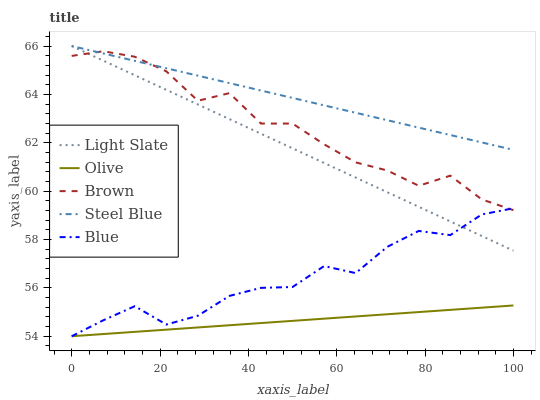Does Olive have the minimum area under the curve?
Answer yes or no. Yes. Does Steel Blue have the maximum area under the curve?
Answer yes or no. Yes. Does Steel Blue have the minimum area under the curve?
Answer yes or no. No. Does Olive have the maximum area under the curve?
Answer yes or no. No. Is Olive the smoothest?
Answer yes or no. Yes. Is Brown the roughest?
Answer yes or no. Yes. Is Steel Blue the smoothest?
Answer yes or no. No. Is Steel Blue the roughest?
Answer yes or no. No. Does Olive have the lowest value?
Answer yes or no. Yes. Does Steel Blue have the lowest value?
Answer yes or no. No. Does Steel Blue have the highest value?
Answer yes or no. Yes. Does Olive have the highest value?
Answer yes or no. No. Is Olive less than Light Slate?
Answer yes or no. Yes. Is Brown greater than Olive?
Answer yes or no. Yes. Does Steel Blue intersect Brown?
Answer yes or no. Yes. Is Steel Blue less than Brown?
Answer yes or no. No. Is Steel Blue greater than Brown?
Answer yes or no. No. Does Olive intersect Light Slate?
Answer yes or no. No. 